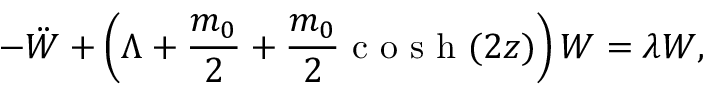<formula> <loc_0><loc_0><loc_500><loc_500>- \ddot { W } + \left ( \Lambda + \frac { m _ { 0 } } { 2 } + \frac { m _ { 0 } } { 2 } \cosh ( 2 z ) \right ) W = \lambda W ,</formula> 